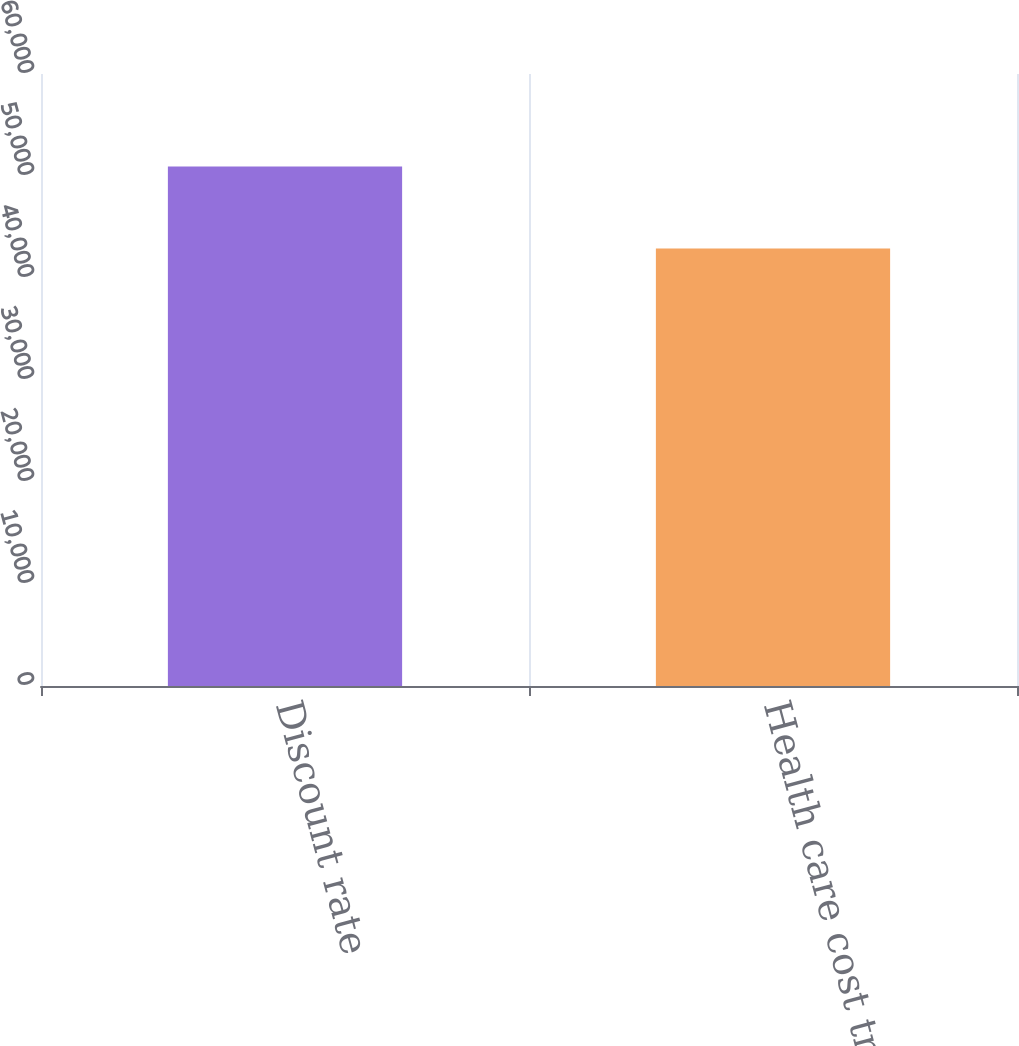<chart> <loc_0><loc_0><loc_500><loc_500><bar_chart><fcel>Discount rate<fcel>Health care cost trend<nl><fcel>50925<fcel>42890<nl></chart> 